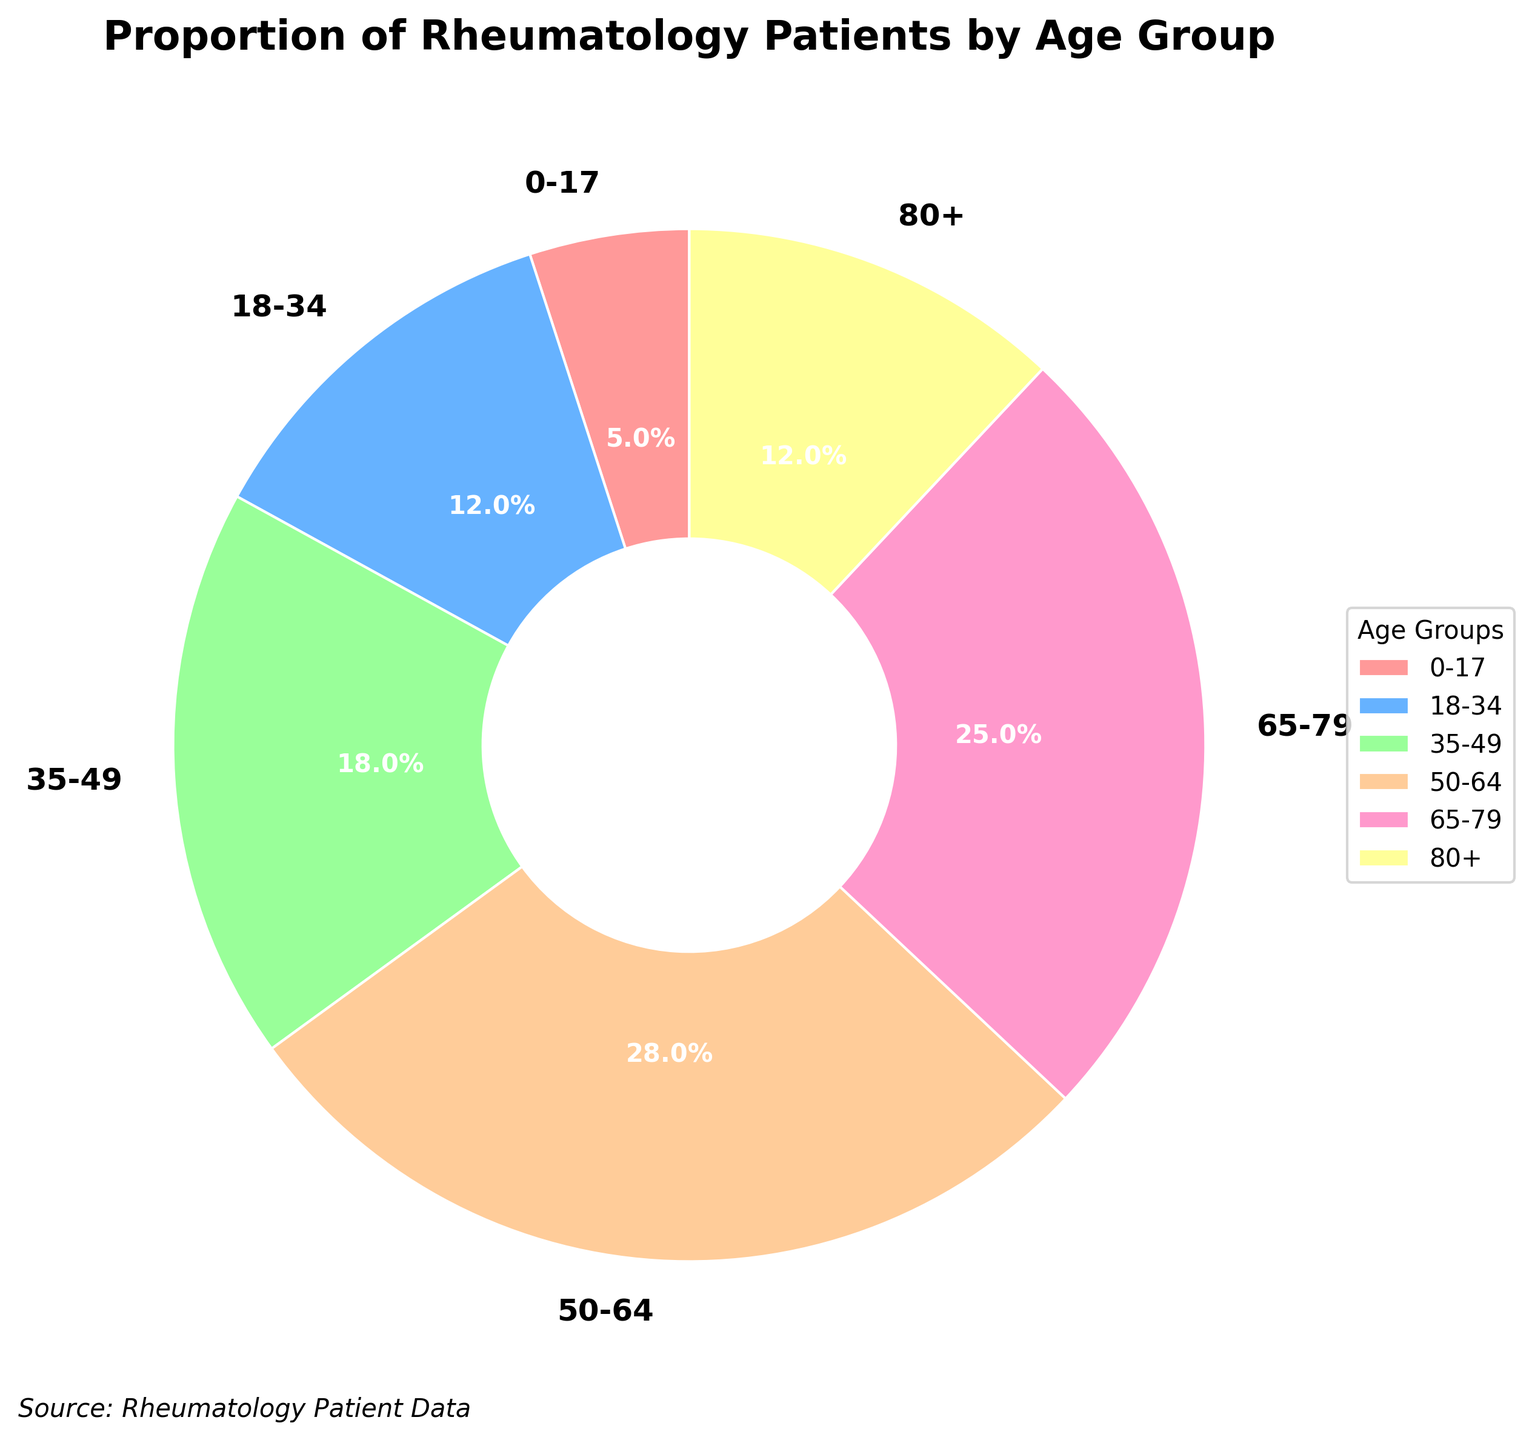What is the proportion of rheumatology patients within the 50-64 age group? Look at the segment labeled "50-64" and refer to the percentage inscribed within that segment.
Answer: 28% Which age group has the smallest proportion of rheumatology patients? Identify the segment with the smallest percentage value; the smallest value is associated with the "0-17" group at 5%.
Answer: 0-17 How do the proportions of patients aged 50-64 and 65-79 compare? Compare the percentages of the two groups. The 50-64 group has 28%, and the 65-79 group has 25%. Since 28% is greater than 25%, the 50-64 group has a larger proportion.
Answer: The 50-64 age group has a larger proportion (28%) compared to the 65-79 age group (25%) What is the combined proportion of rheumatology patients aged 35-49 and 80+? Add the proportions of the 35-49 age group (18%) and the 80+ age group (12%). 18% + 12% = 30%.
Answer: 30% Which age groups have an equal proportion of rheumatology patients? Identify the groups with the same percentage value. Both the 18-34 and 80+ age groups have 12%.
Answer: 18-34 and 80+ What color represents the 65-79 age group in the pie chart? Observe the color of the segment labeled "65-79".
Answer: A shade of pink (lighter pink) Which two adjacent age groups together make up more than half of the total patient distribution? Check combinations of adjacent segments whose joint percentages exceed 50%. The 50-64 age group (28%) and the 65-79 age group (25%) together make up 53%.
Answer: 50-64 and 65-79 How much larger is the proportion of patients in the 35-49 age group compared to the 0-17 age group? Subtract the percentage of the 0-17 group from that of the 35-49 group. 18% - 5% = 13%.
Answer: 13% What is the difference in proportion between the age groups 18-34 and 35-49? Subtract the percentage of the 18-34 age group from that of the 35-49 age group. 18% - 12% = 6%.
Answer: 6% Which color represents the age group with the second highest proportion of rheumatology patients? The second highest proportion (25%) belongs to the 65-79 age group, which is represented by a shade of pink (lighter pink).
Answer: A shade of pink (lighter pink) 